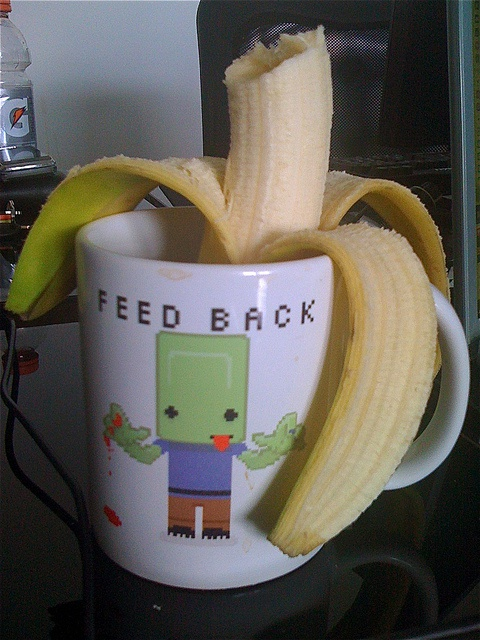Describe the objects in this image and their specific colors. I can see cup in brown, darkgray, gray, olive, and lavender tones, banana in brown, tan, and olive tones, and bottle in brown and gray tones in this image. 